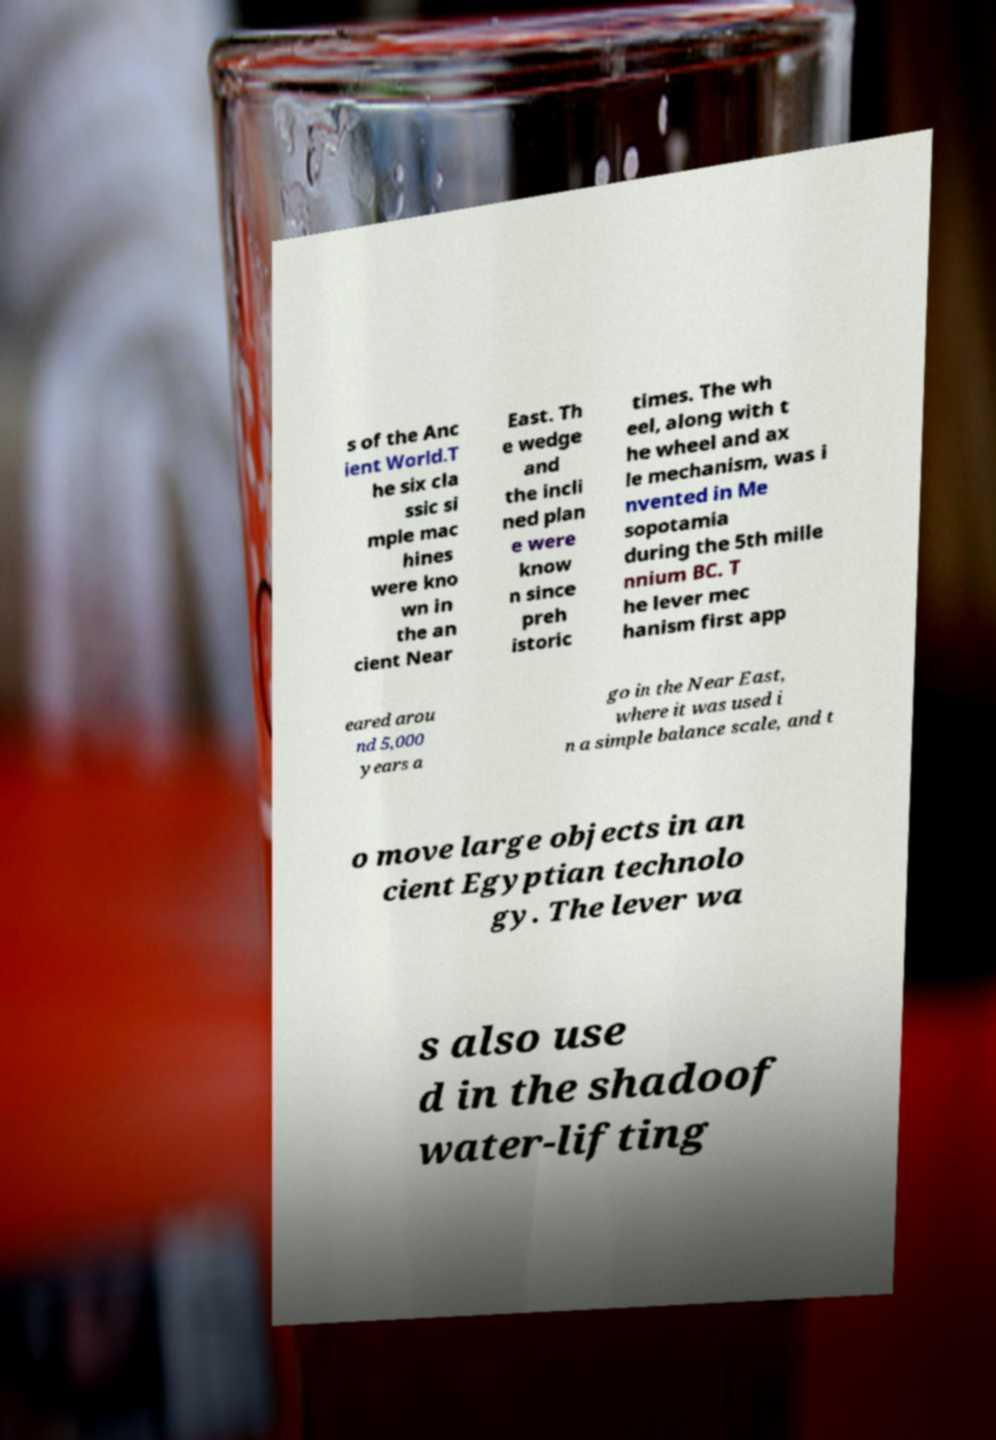Can you read and provide the text displayed in the image?This photo seems to have some interesting text. Can you extract and type it out for me? s of the Anc ient World.T he six cla ssic si mple mac hines were kno wn in the an cient Near East. Th e wedge and the incli ned plan e were know n since preh istoric times. The wh eel, along with t he wheel and ax le mechanism, was i nvented in Me sopotamia during the 5th mille nnium BC. T he lever mec hanism first app eared arou nd 5,000 years a go in the Near East, where it was used i n a simple balance scale, and t o move large objects in an cient Egyptian technolo gy. The lever wa s also use d in the shadoof water-lifting 